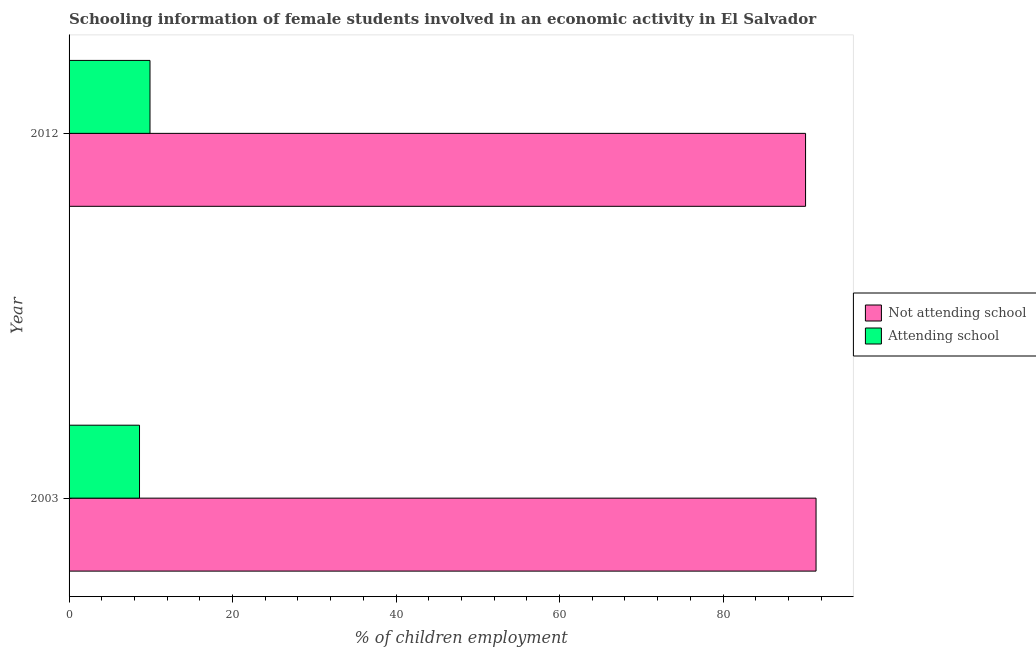How many different coloured bars are there?
Offer a terse response. 2. How many groups of bars are there?
Keep it short and to the point. 2. Are the number of bars per tick equal to the number of legend labels?
Your answer should be compact. Yes. How many bars are there on the 2nd tick from the bottom?
Keep it short and to the point. 2. In how many cases, is the number of bars for a given year not equal to the number of legend labels?
Provide a succinct answer. 0. What is the percentage of employed females who are not attending school in 2012?
Keep it short and to the point. 90.1. Across all years, what is the maximum percentage of employed females who are not attending school?
Your response must be concise. 91.38. Across all years, what is the minimum percentage of employed females who are not attending school?
Give a very brief answer. 90.1. What is the total percentage of employed females who are not attending school in the graph?
Give a very brief answer. 181.48. What is the difference between the percentage of employed females who are attending school in 2003 and that in 2012?
Make the answer very short. -1.28. What is the difference between the percentage of employed females who are not attending school in 2003 and the percentage of employed females who are attending school in 2012?
Keep it short and to the point. 81.48. What is the average percentage of employed females who are not attending school per year?
Give a very brief answer. 90.74. In the year 2012, what is the difference between the percentage of employed females who are not attending school and percentage of employed females who are attending school?
Offer a very short reply. 80.2. In how many years, is the percentage of employed females who are attending school greater than 16 %?
Keep it short and to the point. 0. What is the ratio of the percentage of employed females who are not attending school in 2003 to that in 2012?
Give a very brief answer. 1.01. Is the percentage of employed females who are not attending school in 2003 less than that in 2012?
Ensure brevity in your answer.  No. What does the 1st bar from the top in 2003 represents?
Provide a short and direct response. Attending school. What does the 2nd bar from the bottom in 2003 represents?
Provide a short and direct response. Attending school. Are all the bars in the graph horizontal?
Offer a terse response. Yes. What is the difference between two consecutive major ticks on the X-axis?
Offer a very short reply. 20. Are the values on the major ticks of X-axis written in scientific E-notation?
Your answer should be very brief. No. Does the graph contain any zero values?
Ensure brevity in your answer.  No. How many legend labels are there?
Ensure brevity in your answer.  2. What is the title of the graph?
Offer a terse response. Schooling information of female students involved in an economic activity in El Salvador. Does "Research and Development" appear as one of the legend labels in the graph?
Ensure brevity in your answer.  No. What is the label or title of the X-axis?
Your response must be concise. % of children employment. What is the label or title of the Y-axis?
Provide a succinct answer. Year. What is the % of children employment of Not attending school in 2003?
Keep it short and to the point. 91.38. What is the % of children employment of Attending school in 2003?
Give a very brief answer. 8.62. What is the % of children employment in Not attending school in 2012?
Your answer should be compact. 90.1. Across all years, what is the maximum % of children employment of Not attending school?
Provide a succinct answer. 91.38. Across all years, what is the minimum % of children employment of Not attending school?
Your answer should be compact. 90.1. Across all years, what is the minimum % of children employment of Attending school?
Provide a succinct answer. 8.62. What is the total % of children employment in Not attending school in the graph?
Offer a terse response. 181.48. What is the total % of children employment of Attending school in the graph?
Offer a terse response. 18.52. What is the difference between the % of children employment in Not attending school in 2003 and that in 2012?
Give a very brief answer. 1.28. What is the difference between the % of children employment of Attending school in 2003 and that in 2012?
Make the answer very short. -1.28. What is the difference between the % of children employment in Not attending school in 2003 and the % of children employment in Attending school in 2012?
Offer a very short reply. 81.48. What is the average % of children employment of Not attending school per year?
Your answer should be compact. 90.74. What is the average % of children employment of Attending school per year?
Your answer should be very brief. 9.26. In the year 2003, what is the difference between the % of children employment of Not attending school and % of children employment of Attending school?
Offer a very short reply. 82.77. In the year 2012, what is the difference between the % of children employment of Not attending school and % of children employment of Attending school?
Your answer should be very brief. 80.2. What is the ratio of the % of children employment in Not attending school in 2003 to that in 2012?
Offer a very short reply. 1.01. What is the ratio of the % of children employment of Attending school in 2003 to that in 2012?
Provide a short and direct response. 0.87. What is the difference between the highest and the second highest % of children employment in Not attending school?
Offer a terse response. 1.28. What is the difference between the highest and the second highest % of children employment in Attending school?
Give a very brief answer. 1.28. What is the difference between the highest and the lowest % of children employment of Not attending school?
Your response must be concise. 1.28. What is the difference between the highest and the lowest % of children employment in Attending school?
Your response must be concise. 1.28. 